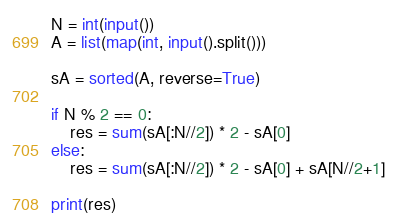<code> <loc_0><loc_0><loc_500><loc_500><_Python_>N = int(input())
A = list(map(int, input().split()))

sA = sorted(A, reverse=True)

if N % 2 == 0:
    res = sum(sA[:N//2]) * 2 - sA[0]
else:
    res = sum(sA[:N//2]) * 2 - sA[0] + sA[N//2+1]

print(res)</code> 